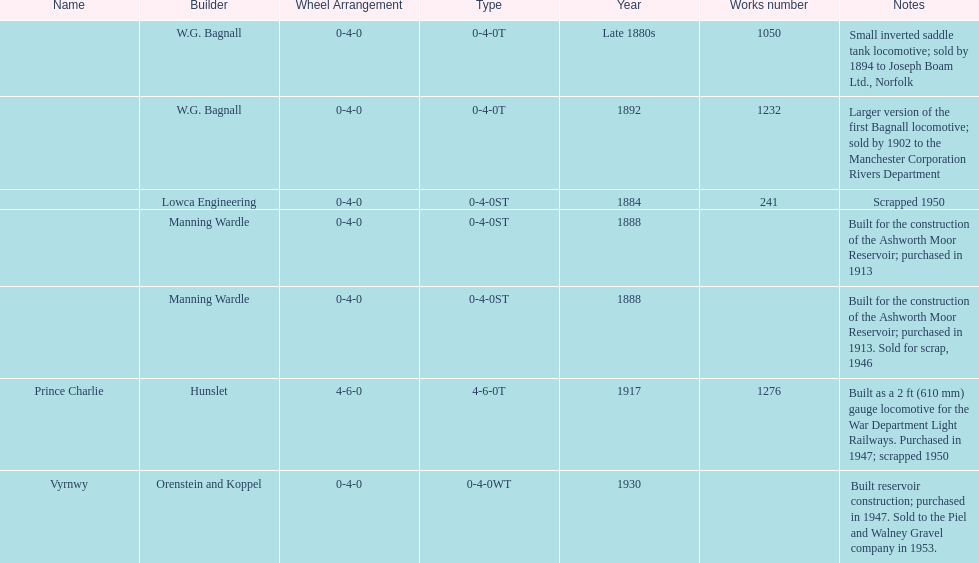How many locomotives were scrapped? 3. 